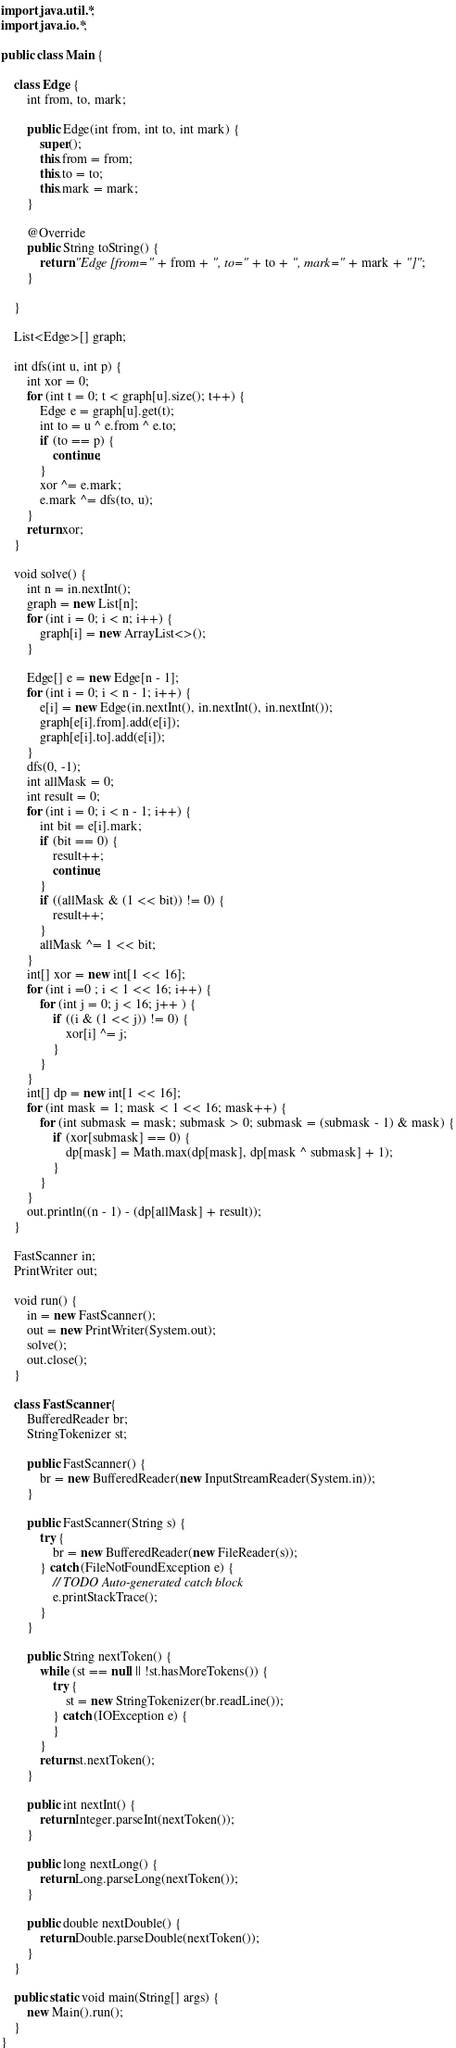Convert code to text. <code><loc_0><loc_0><loc_500><loc_500><_Java_>import java.util.*;
import java.io.*;

public class Main {

	class Edge {
		int from, to, mark;

		public Edge(int from, int to, int mark) {
			super();
			this.from = from;
			this.to = to;
			this.mark = mark;
		}

		@Override
		public String toString() {
			return "Edge [from=" + from + ", to=" + to + ", mark=" + mark + "]";
		}
		
	}
	
	List<Edge>[] graph;
	
	int dfs(int u, int p) {
		int xor = 0;
		for (int t = 0; t < graph[u].size(); t++) {
			Edge e = graph[u].get(t);
			int to = u ^ e.from ^ e.to;
			if (to == p) {
				continue;
			}
			xor ^= e.mark;
			e.mark ^= dfs(to, u);
		}
		return xor;
	}
	
	void solve() {
		int n = in.nextInt();
		graph = new List[n];
		for (int i = 0; i < n; i++) {
			graph[i] = new ArrayList<>();
		}
		
		Edge[] e = new Edge[n - 1];
		for (int i = 0; i < n - 1; i++) {
			e[i] = new Edge(in.nextInt(), in.nextInt(), in.nextInt());
			graph[e[i].from].add(e[i]);
			graph[e[i].to].add(e[i]);
		}
		dfs(0, -1);
		int allMask = 0;
		int result = 0;
		for (int i = 0; i < n - 1; i++) {
			int bit = e[i].mark;
			if (bit == 0) {
				result++;
				continue;
			}
			if ((allMask & (1 << bit)) != 0) {
				result++;
			}
			allMask ^= 1 << bit;
		}
		int[] xor = new int[1 << 16];
		for (int i =0 ; i < 1 << 16; i++) {
			for (int j = 0; j < 16; j++ ) {
				if ((i & (1 << j)) != 0) {
					xor[i] ^= j;
				}
			}
		}
		int[] dp = new int[1 << 16];
		for (int mask = 1; mask < 1 << 16; mask++) {
			for (int submask = mask; submask > 0; submask = (submask - 1) & mask) {
				if (xor[submask] == 0) {
					dp[mask] = Math.max(dp[mask], dp[mask ^ submask] + 1);
				}
			}
		}
		out.println((n - 1) - (dp[allMask] + result));
	}

	FastScanner in;
	PrintWriter out;

	void run() {
		in = new FastScanner();
		out = new PrintWriter(System.out);
		solve();
		out.close();
	}

	class FastScanner {
		BufferedReader br;
		StringTokenizer st;

		public FastScanner() {
			br = new BufferedReader(new InputStreamReader(System.in));
		}

		public FastScanner(String s) {
			try {
				br = new BufferedReader(new FileReader(s));
			} catch (FileNotFoundException e) {
				// TODO Auto-generated catch block
				e.printStackTrace();
			}
		}

		public String nextToken() {
			while (st == null || !st.hasMoreTokens()) {
				try {
					st = new StringTokenizer(br.readLine());
				} catch (IOException e) {
				}
			}
			return st.nextToken();
		}

		public int nextInt() {
			return Integer.parseInt(nextToken());
		}

		public long nextLong() {
			return Long.parseLong(nextToken());
		}

		public double nextDouble() {
			return Double.parseDouble(nextToken());
		}
	}

	public static void main(String[] args) {
		new Main().run();
	}
}
</code> 